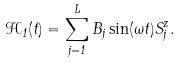<formula> <loc_0><loc_0><loc_500><loc_500>\mathcal { H } _ { 1 } ( t ) = \sum _ { j = 1 } ^ { L } B _ { j } \sin ( \omega t ) S ^ { z } _ { j } .</formula> 